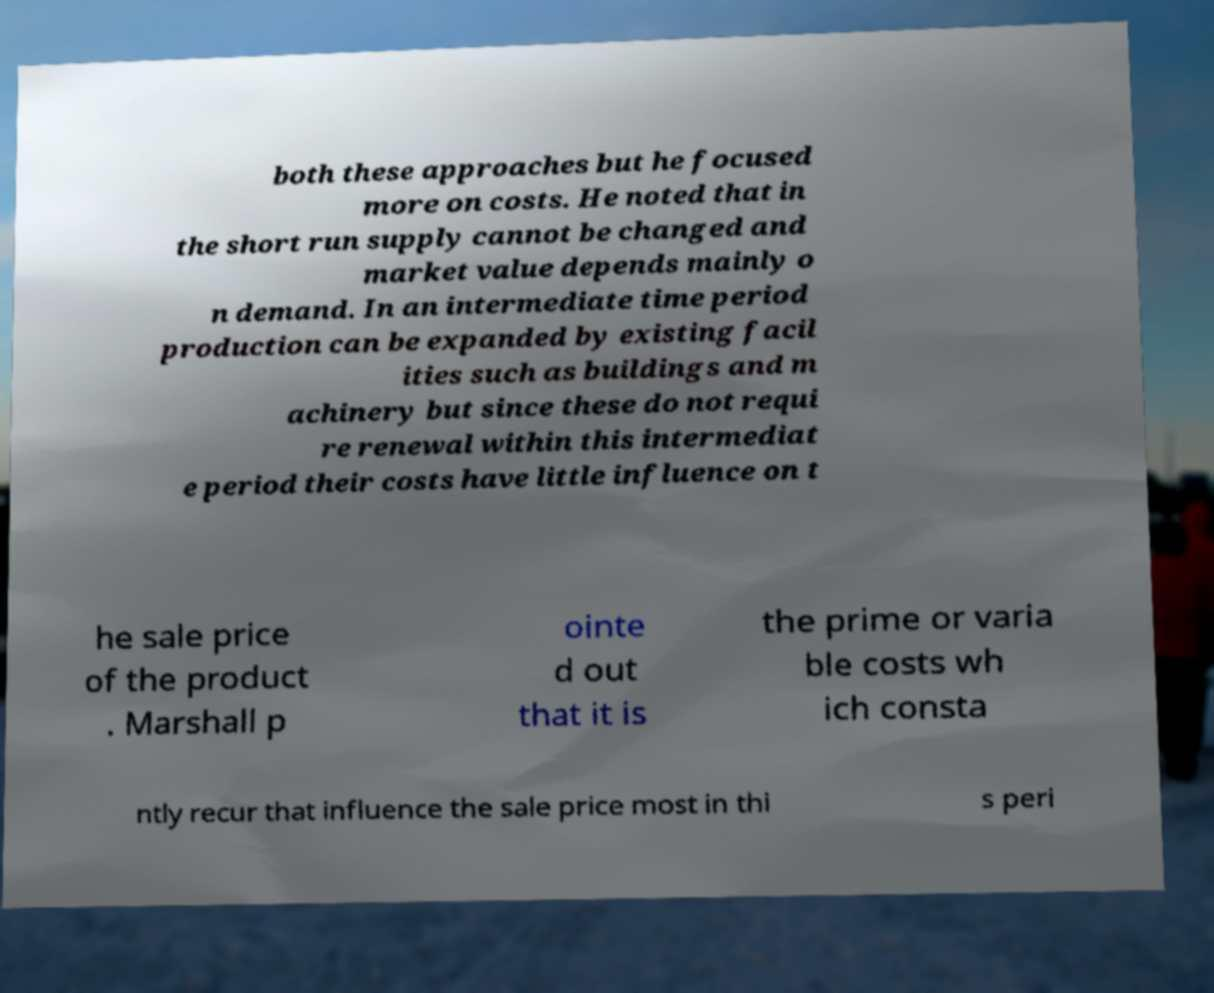Could you extract and type out the text from this image? both these approaches but he focused more on costs. He noted that in the short run supply cannot be changed and market value depends mainly o n demand. In an intermediate time period production can be expanded by existing facil ities such as buildings and m achinery but since these do not requi re renewal within this intermediat e period their costs have little influence on t he sale price of the product . Marshall p ointe d out that it is the prime or varia ble costs wh ich consta ntly recur that influence the sale price most in thi s peri 